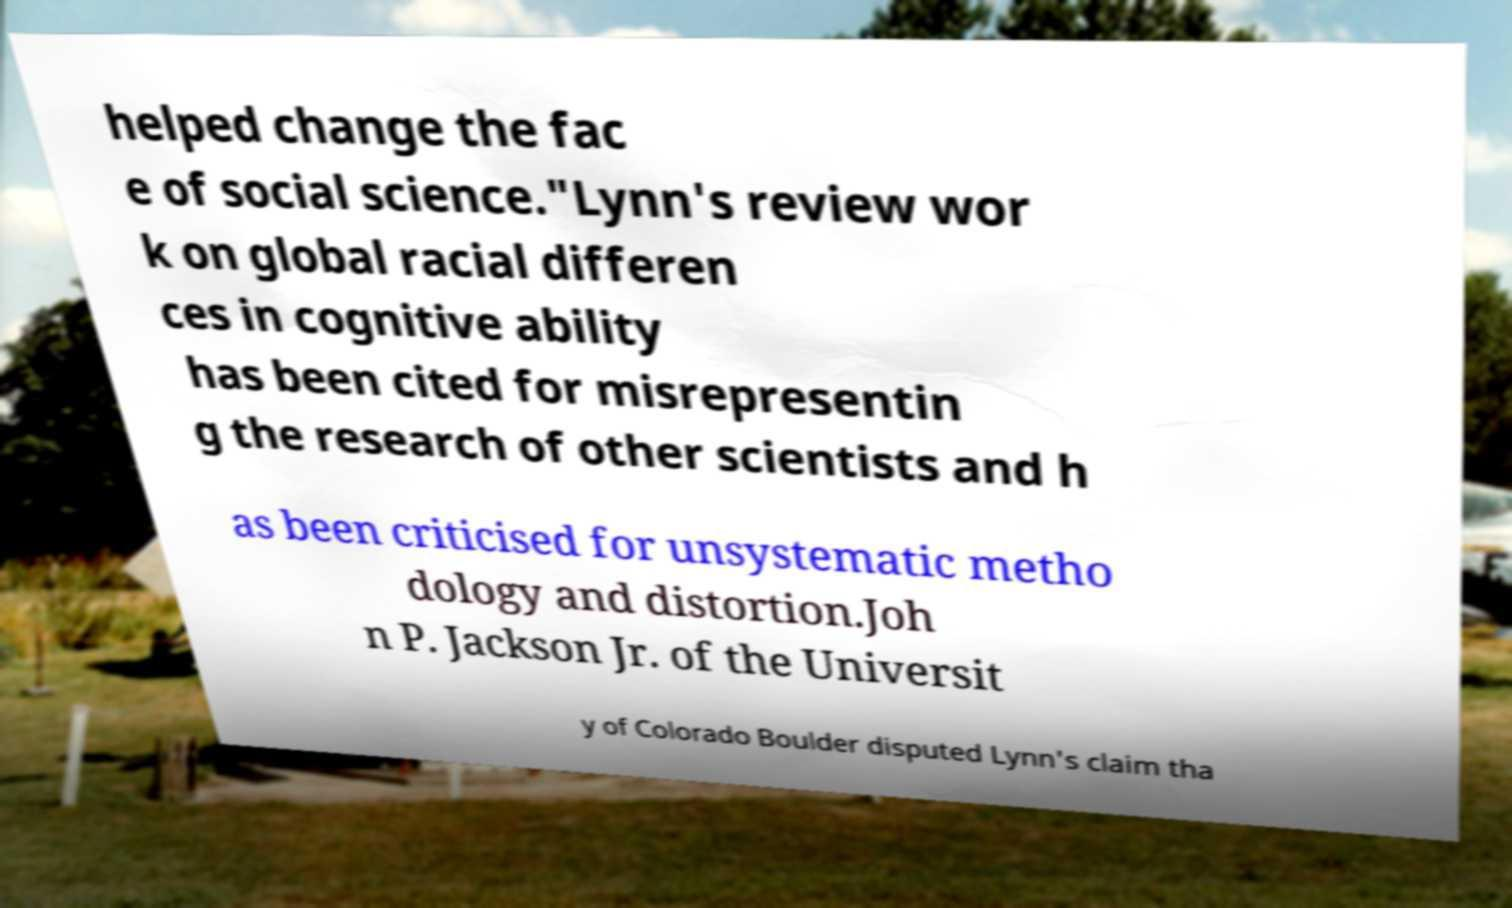Can you accurately transcribe the text from the provided image for me? helped change the fac e of social science."Lynn's review wor k on global racial differen ces in cognitive ability has been cited for misrepresentin g the research of other scientists and h as been criticised for unsystematic metho dology and distortion.Joh n P. Jackson Jr. of the Universit y of Colorado Boulder disputed Lynn's claim tha 